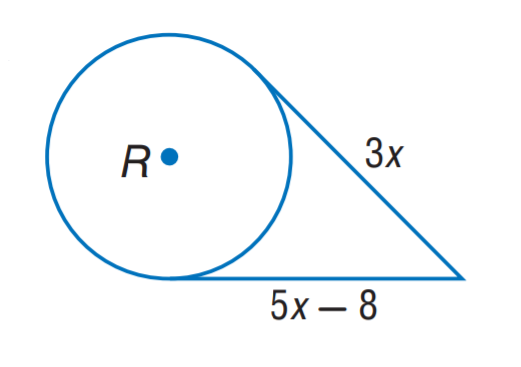Question: The segment is tangent to the circle. Find x.
Choices:
A. 3
B. 4
C. 5
D. 8
Answer with the letter. Answer: B 